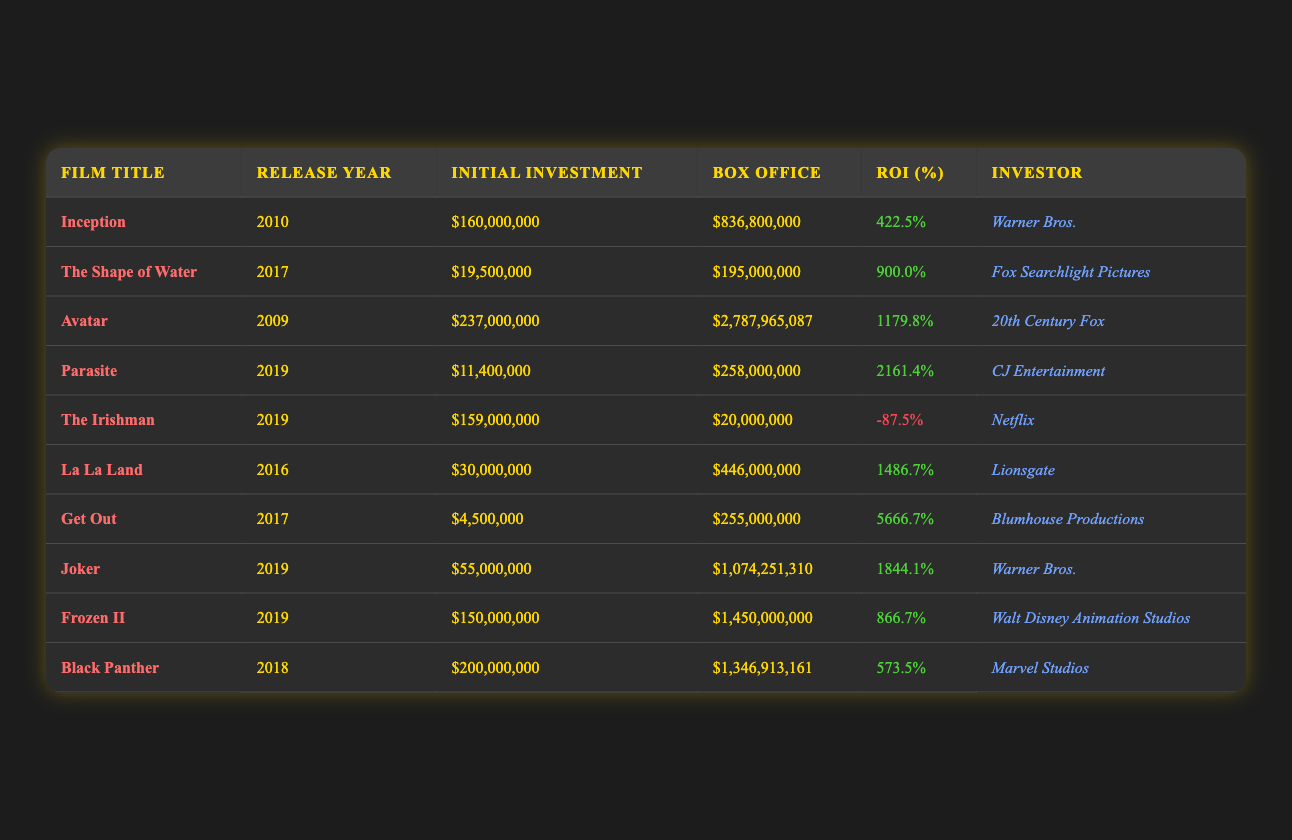What is the highest return on investment percentage among the films listed? The table shows various films with their return on investment percentages. Scanning through the ROI percentages, "Parasite" has the highest ROI at 2161.4%.
Answer: 2161.4% Which film had the lowest box office earnings? The table lists the box office earnings for each film. "The Irishman" has the lowest earnings at $20,000,000.
Answer: $20,000,000 What is the average initial investment for the films? To calculate the average initial investment, sum the initial investments: 160,000,000 + 19,500,000 + 237,000,000 + 11,400,000 + 159,000,000 + 30,000,000 + 4,500,000 + 55,000,000 + 150,000,000 + 200,000,000 = 1,571,400,000. There are 10 films, so 1,571,400,000 / 10 = 157,140,000.
Answer: $157,140,000 True or False: "Get Out" had a return on investment greater than 5000%. The ROI for "Get Out" is listed as 5666.7%, which is indeed greater than 5000%. Therefore, the statement is true.
Answer: True Which investor had the highest return on investment film? The film produced by CJ Entertainment, "Parasite," shows the highest ROI of 2161.4%, indicating CJ Entertainment had the highest return on investment.
Answer: CJ Entertainment What is the difference in ROI between "Avatar" and "The Shape of Water"? The ROI for "Avatar" is 1179.8% and for "The Shape of Water" is 900.0%. The difference is 1179.8 - 900.0 = 279.8%.
Answer: 279.8% Which film had a negative return on investment? Scanning the table for any negative ROI shows that "The Irishman" has an ROI of -87.5%, indicating it had a negative return.
Answer: The Irishman What is the total box office earnings for films from 2019? The films from 2019 listed in the table are "Parasite," "Joker," "Frozen II," and "The Irishman." Their box office earnings are 258,000,000 + 1,074,251,310 + 1,450,000,000 + 20,000,000 = 2,802,251,310.
Answer: $2,802,251,310 Which film released in 2017 had the highest box office? The films from 2017 listed in the table are "The Shape of Water" and "Get Out." "Get Out" had a box office of $255,000,000 which is higher than "The Shape of Water" at $195,000,000.
Answer: Get Out Are there more films with a positive return or negative return on investment? By examining the table, there are 9 films with positive returns and 1 film with a negative return (The Irishman). Therefore, there are more films with a positive return on investment.
Answer: Positive returns 